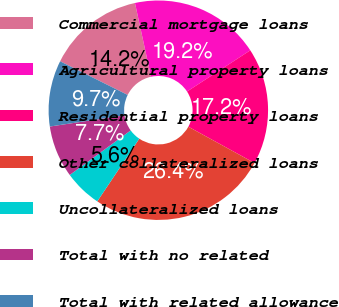Convert chart. <chart><loc_0><loc_0><loc_500><loc_500><pie_chart><fcel>Commercial mortgage loans<fcel>Agricultural property loans<fcel>Residential property loans<fcel>Other collateralized loans<fcel>Uncollateralized loans<fcel>Total with no related<fcel>Total with related allowance<nl><fcel>14.23%<fcel>19.23%<fcel>17.18%<fcel>26.4%<fcel>5.56%<fcel>7.67%<fcel>9.73%<nl></chart> 